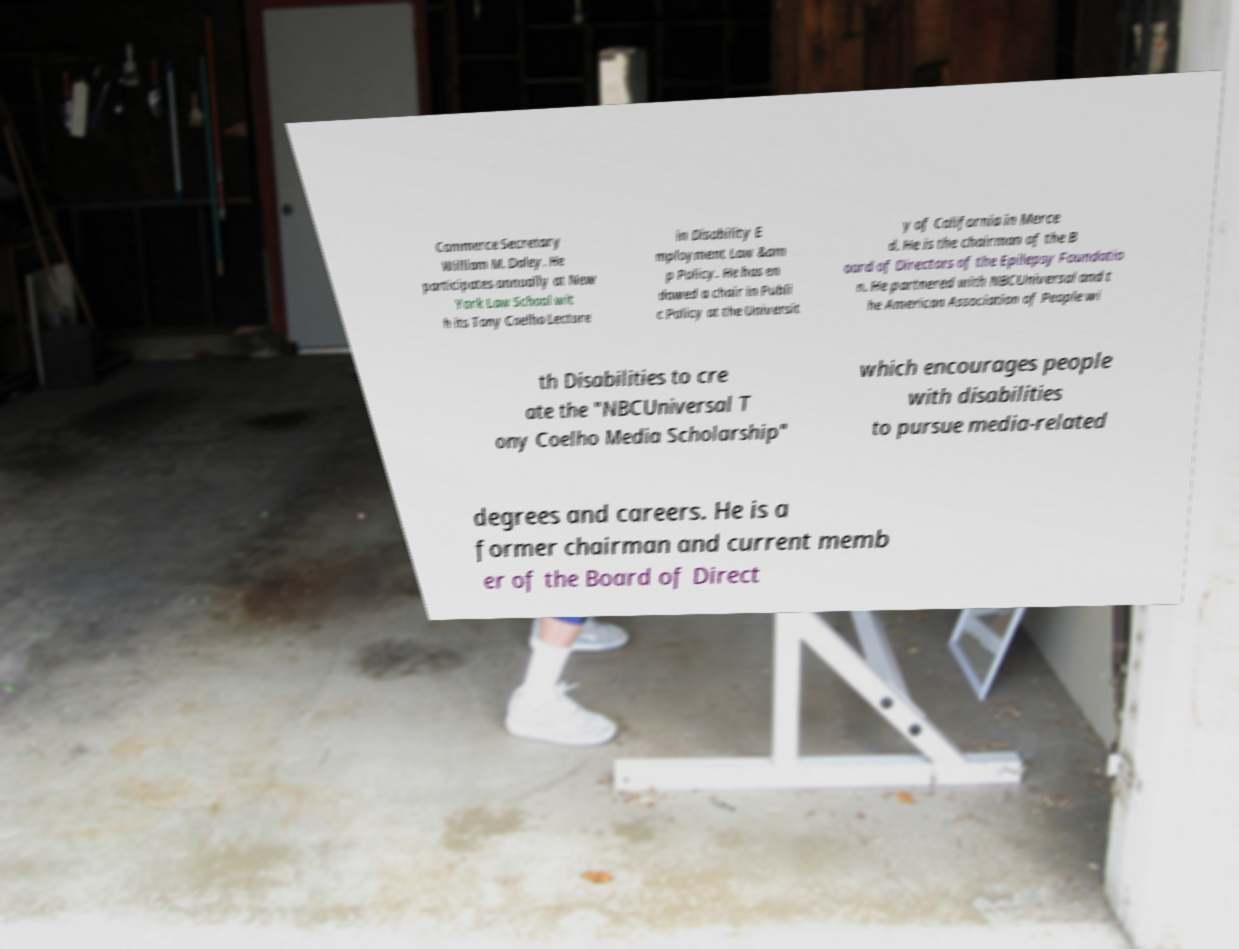Please identify and transcribe the text found in this image. Commerce Secretary William M. Daley. He participates annually at New York Law School wit h its Tony Coelho Lecture in Disability E mployment Law &am p Policy. He has en dowed a chair in Publi c Policy at the Universit y of California in Merce d. He is the chairman of the B oard of Directors of the Epilepsy Foundatio n. He partnered with NBCUniversal and t he American Association of People wi th Disabilities to cre ate the "NBCUniversal T ony Coelho Media Scholarship" which encourages people with disabilities to pursue media-related degrees and careers. He is a former chairman and current memb er of the Board of Direct 